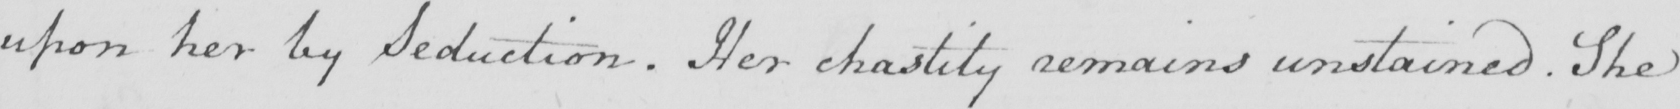What is written in this line of handwriting? upon her by Seduction . Her chastity remains unstained . She 